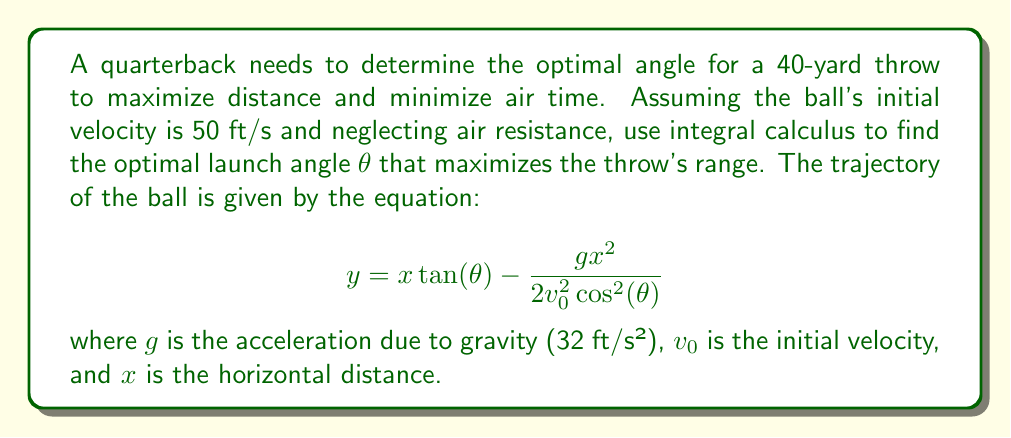Provide a solution to this math problem. To find the optimal angle, we need to maximize the range R of the throw. The range is given by:

$$R = \frac{v_0^2\sin(2\theta)}{g}$$

1. To maximize R, we need to find the value of θ where the derivative of R with respect to θ is zero:

   $$\frac{dR}{d\theta} = \frac{2v_0^2\cos(2\theta)}{g} = 0$$

2. Solving this equation:
   $$\cos(2\theta) = 0$$
   $$2\theta = \frac{\pi}{2}$$
   $$\theta = \frac{\pi}{4} = 45°$$

3. To confirm this is a maximum, we can check the second derivative:

   $$\frac{d^2R}{d\theta^2} = -\frac{4v_0^2\sin(2\theta)}{g}$$

   At θ = 45°, this is negative, confirming a maximum.

4. We can verify the result by calculating the range:

   $$R = \frac{(50\text{ ft/s})^2 \sin(2 \cdot 45°)}{32\text{ ft/s}^2} = \frac{2500}{32} \approx 78.125\text{ ft}$$

   This is indeed greater than 40 yards (120 ft), so the ball will reach its target.

5. The time of flight can be calculated using:

   $$t = \frac{2v_0\sin(\theta)}{g} = \frac{2 \cdot 50 \cdot \sin(45°)}{32} \approx 2.21\text{ s}$$

This optimal angle maximizes distance while minimizing air time, which is crucial for avoiding interceptions and hitting receivers in stride.
Answer: 45° 